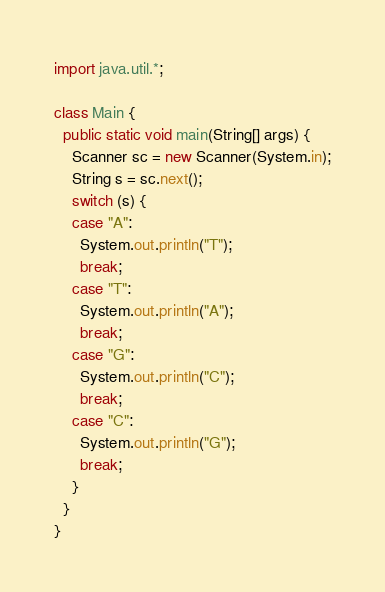Convert code to text. <code><loc_0><loc_0><loc_500><loc_500><_Java_>import java.util.*;

class Main {
  public static void main(String[] args) {
    Scanner sc = new Scanner(System.in);
    String s = sc.next();
    switch (s) {
    case "A":
      System.out.println("T");
      break;
    case "T":
      System.out.println("A");
      break;
    case "G":
      System.out.println("C");
      break;
    case "C":
      System.out.println("G");
      break;
    }
  }
}</code> 